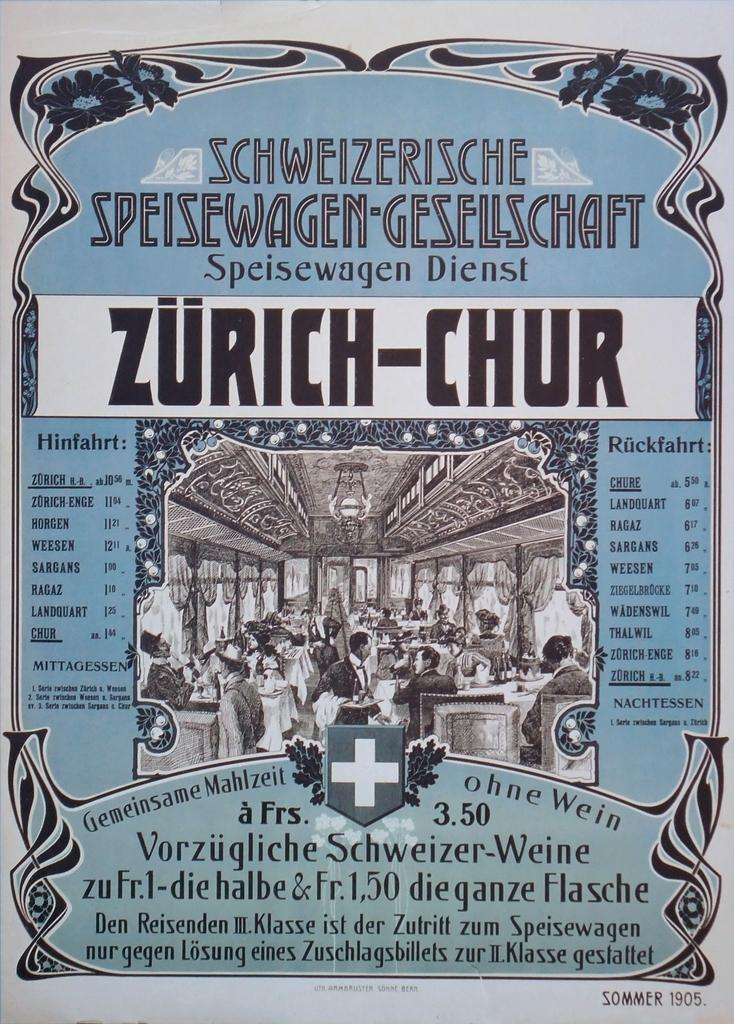<image>
Present a compact description of the photo's key features. A very old Swiss menu lists prices of its offerings. 